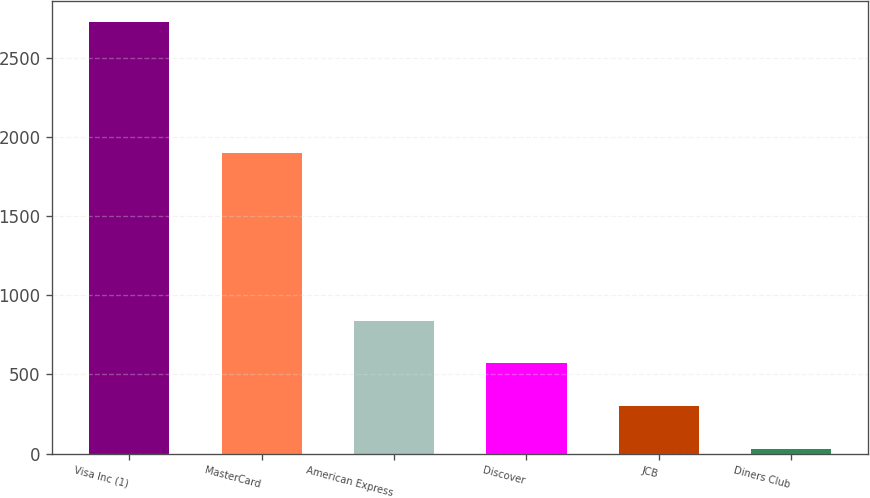<chart> <loc_0><loc_0><loc_500><loc_500><bar_chart><fcel>Visa Inc (1)<fcel>MasterCard<fcel>American Express<fcel>Discover<fcel>JCB<fcel>Diners Club<nl><fcel>2727<fcel>1900<fcel>839.1<fcel>569.4<fcel>299.7<fcel>30<nl></chart> 